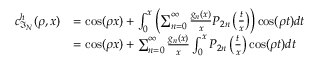Convert formula to latex. <formula><loc_0><loc_0><loc_500><loc_500>\begin{array} { r l } { c _ { \mathfrak { I } _ { N } } ^ { h } ( \rho , x ) } & { = \cos ( \rho x ) + \int _ { 0 } ^ { x } \left ( \sum _ { n = 0 } ^ { \infty } \frac { g _ { n } ( x ) } { x } P _ { 2 n } \left ( \frac { t } { x } \right ) \right ) \cos ( \rho t ) d t } \\ & { = \cos ( \rho x ) + \sum _ { n = 0 } ^ { \infty } \frac { g _ { n } ( x ) } { x } \int _ { 0 } ^ { x } P _ { 2 n } \left ( \frac { t } { x } \right ) \cos ( \rho t ) d t } \end{array}</formula> 